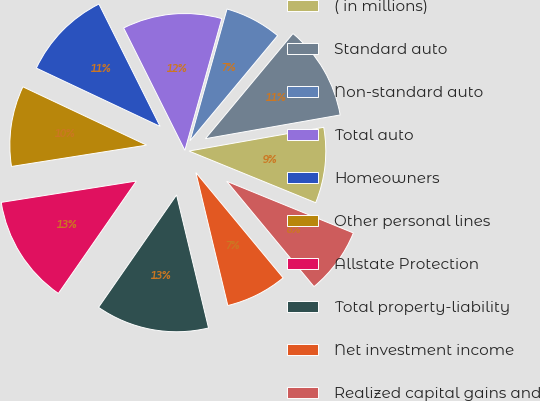Convert chart. <chart><loc_0><loc_0><loc_500><loc_500><pie_chart><fcel>( in millions)<fcel>Standard auto<fcel>Non-standard auto<fcel>Total auto<fcel>Homeowners<fcel>Other personal lines<fcel>Allstate Protection<fcel>Total property-liability<fcel>Net investment income<fcel>Realized capital gains and<nl><fcel>8.94%<fcel>11.17%<fcel>6.7%<fcel>11.73%<fcel>10.61%<fcel>9.5%<fcel>12.85%<fcel>13.41%<fcel>7.26%<fcel>7.82%<nl></chart> 